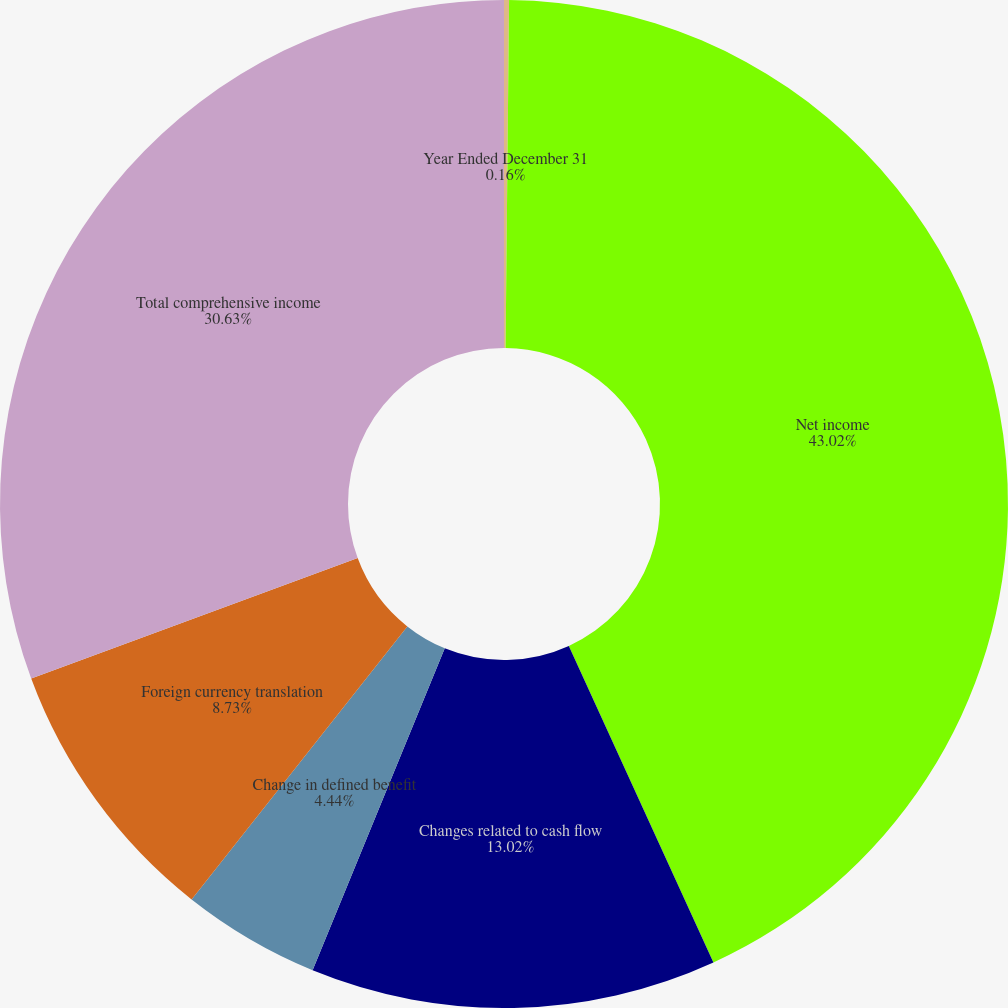Convert chart. <chart><loc_0><loc_0><loc_500><loc_500><pie_chart><fcel>Year Ended December 31<fcel>Net income<fcel>Changes related to cash flow<fcel>Change in defined benefit<fcel>Foreign currency translation<fcel>Total comprehensive income<nl><fcel>0.16%<fcel>43.02%<fcel>13.02%<fcel>4.44%<fcel>8.73%<fcel>30.63%<nl></chart> 